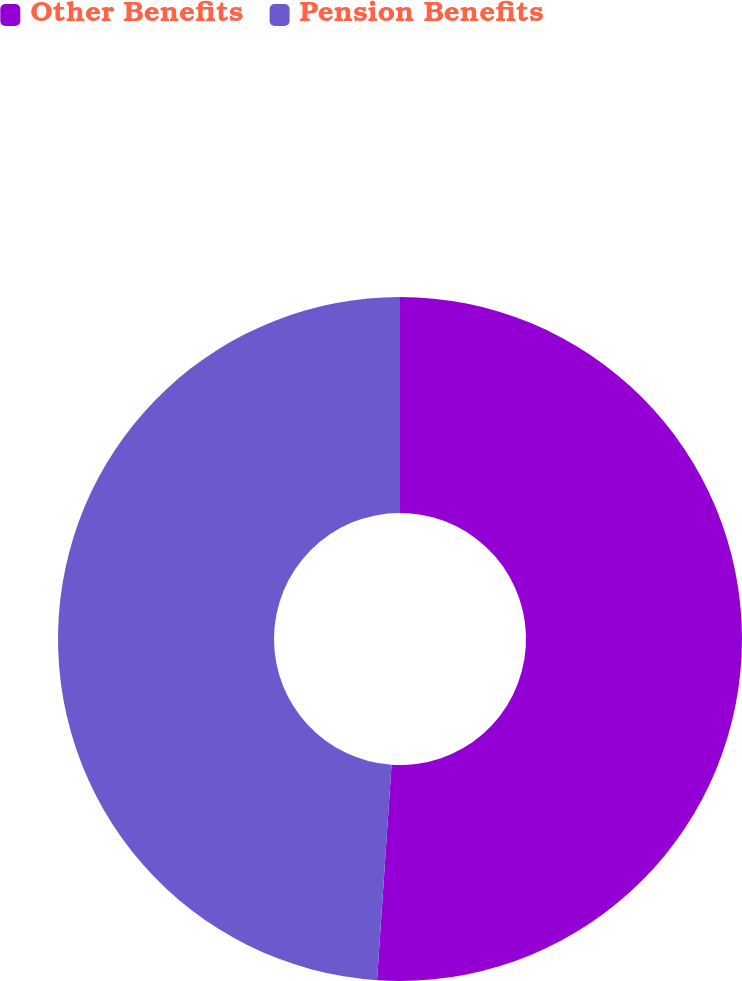Convert chart. <chart><loc_0><loc_0><loc_500><loc_500><pie_chart><fcel>Other Benefits<fcel>Pension Benefits<nl><fcel>51.07%<fcel>48.93%<nl></chart> 